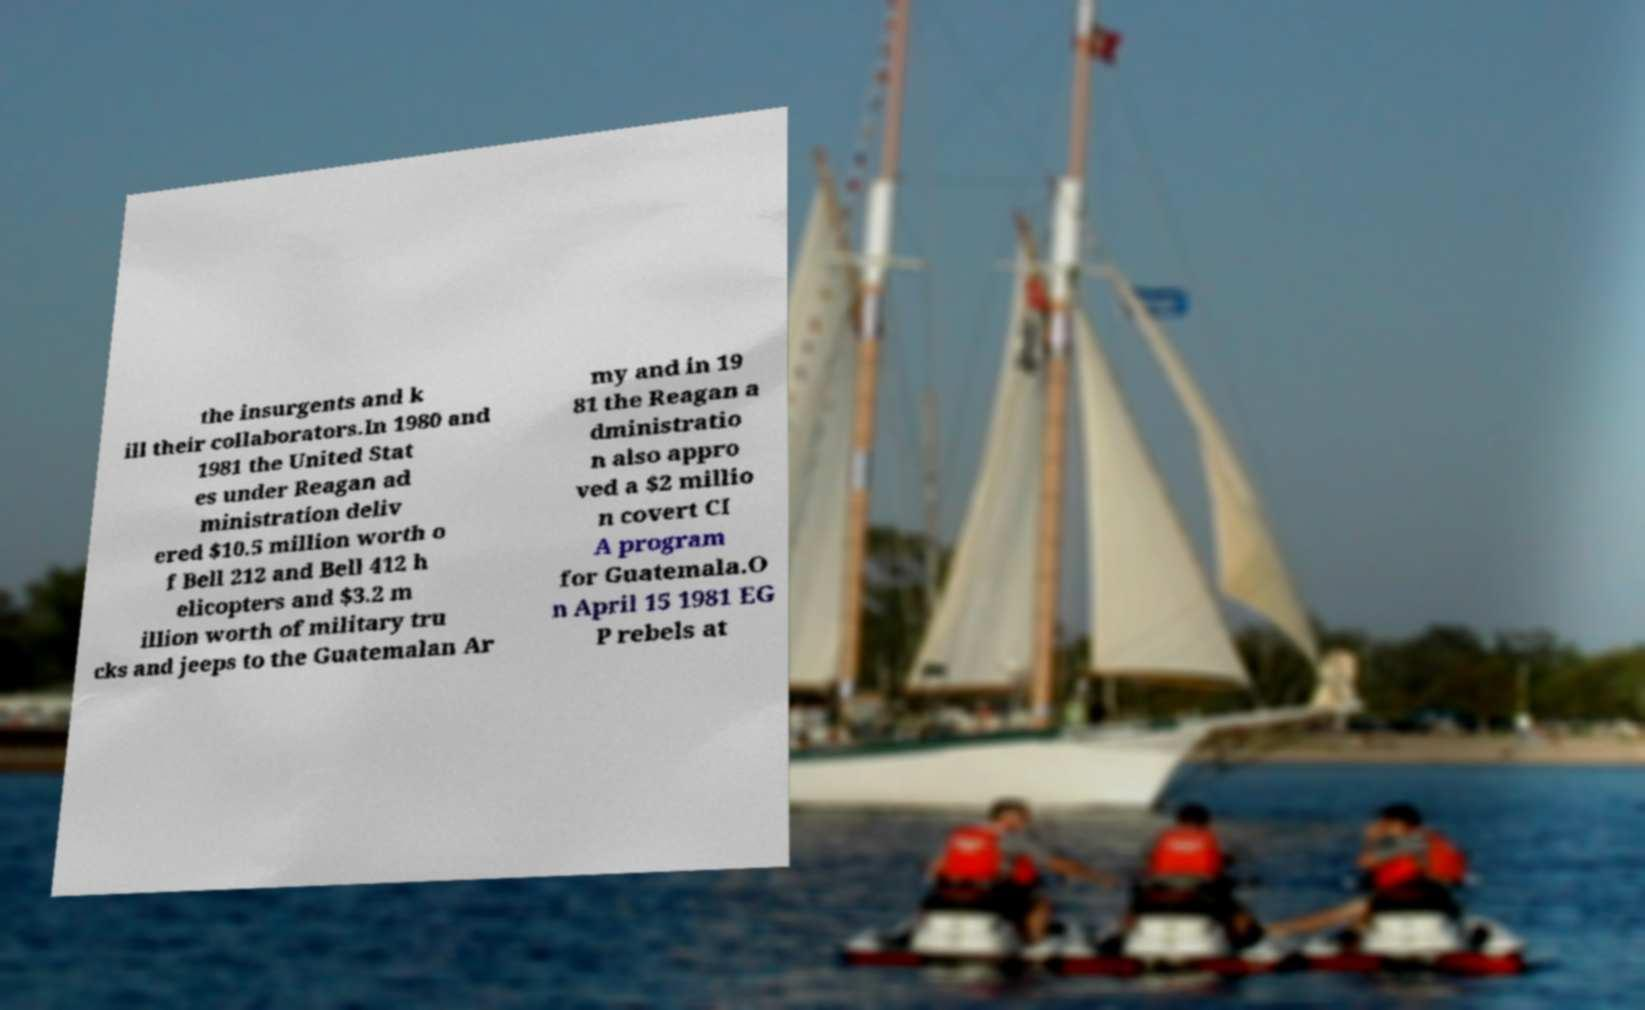Can you accurately transcribe the text from the provided image for me? the insurgents and k ill their collaborators.In 1980 and 1981 the United Stat es under Reagan ad ministration deliv ered $10.5 million worth o f Bell 212 and Bell 412 h elicopters and $3.2 m illion worth of military tru cks and jeeps to the Guatemalan Ar my and in 19 81 the Reagan a dministratio n also appro ved a $2 millio n covert CI A program for Guatemala.O n April 15 1981 EG P rebels at 